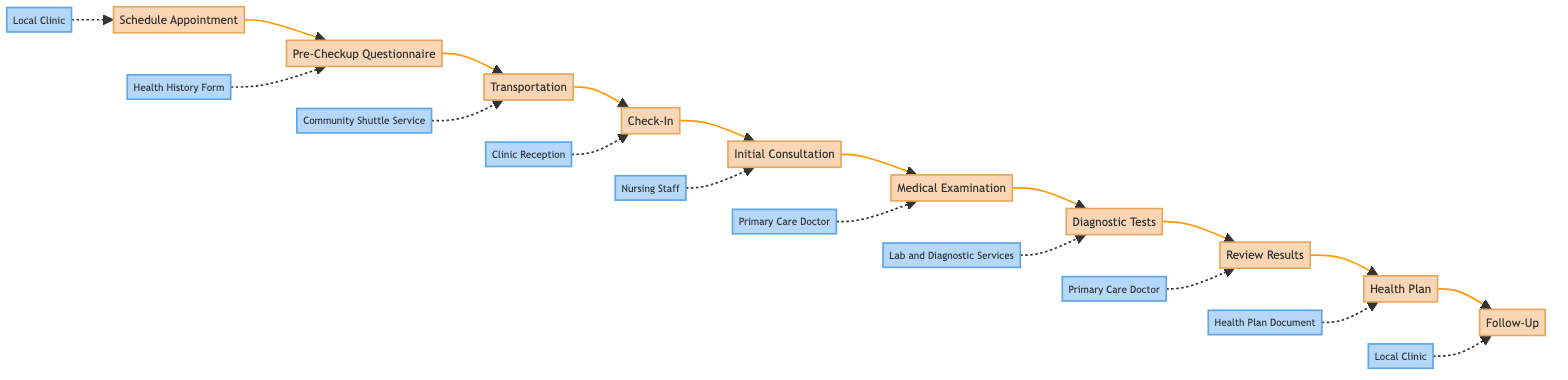What is the first step in the health checkup routine? The first step in the diagram is "Schedule Appointment", which is indicated as the starting point in the horizontal flow.
Answer: Schedule Appointment How many main steps are there in the health checkup routine? By counting the boxes in the flowchart, there are a total of 10 main steps outlined, each leading to the next in a sequential manner.
Answer: 10 What is the entity associated with the "Check-In" step? The entity that corresponds with the "Check-In" step is "Clinic Reception", which is displayed as a connected label beneath that step in the flowchart.
Answer: Clinic Reception Where does the "Diagnostic Tests" step occur in the sequence? The "Diagnostic Tests" step follows the "Medical Examination" step and precedes the "Review Results" step, making it the seventh step in the sequence.
Answer: After Medical Examination What service can assist with transportation to the clinic? The service mentioned for transportation is the "Community Shuttle Service", which is explicitly linked to the "Transportation" step in the flowchart.
Answer: Community Shuttle Service Which step comes immediately after the "Review Results"? Following the "Review Results" step, the next step in the diagram is "Health Plan", clearly indicating the flow of the procedure.
Answer: Health Plan Who performs the Medical Examination? The "Primary Care Doctor" is the entity responsible for conducting the Medical Examination, as shown in the flowchart next to that step.
Answer: Primary Care Doctor How does the flowchart describe the purpose of the "Health Plan" step? The "Health Plan" step provides a personalized health plan, which includes medication, lifestyle changes, and follow-up appointments, emphasizing its importance in the routine.
Answer: Personalized health plan What type of tests are indicated in the "Diagnostic Tests" step? The "Diagnostic Tests" step mentions undergoing tests such as blood tests, ECG, or X-rays, showcasing the range of tests conducted during the checkup process.
Answer: Blood tests, ECG, X-rays What do you do after receiving the Health Plan? After receiving the Health Plan, it is necessary to "Follow-Up", which involves scheduling and attending further appointments as indicated in the plan.
Answer: Follow-Up 